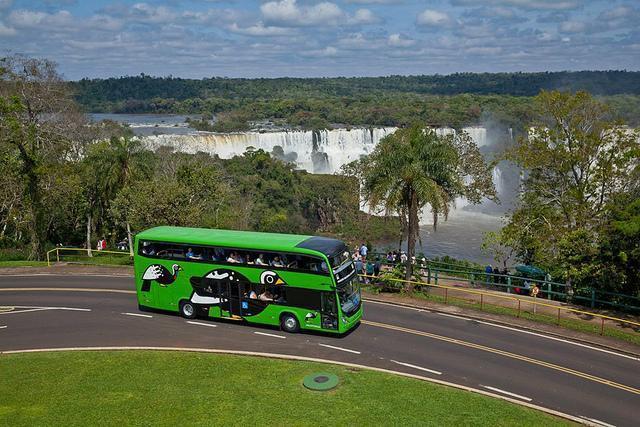How many levels of seating are on the bus?
Give a very brief answer. 2. How many buses are there?
Give a very brief answer. 1. 